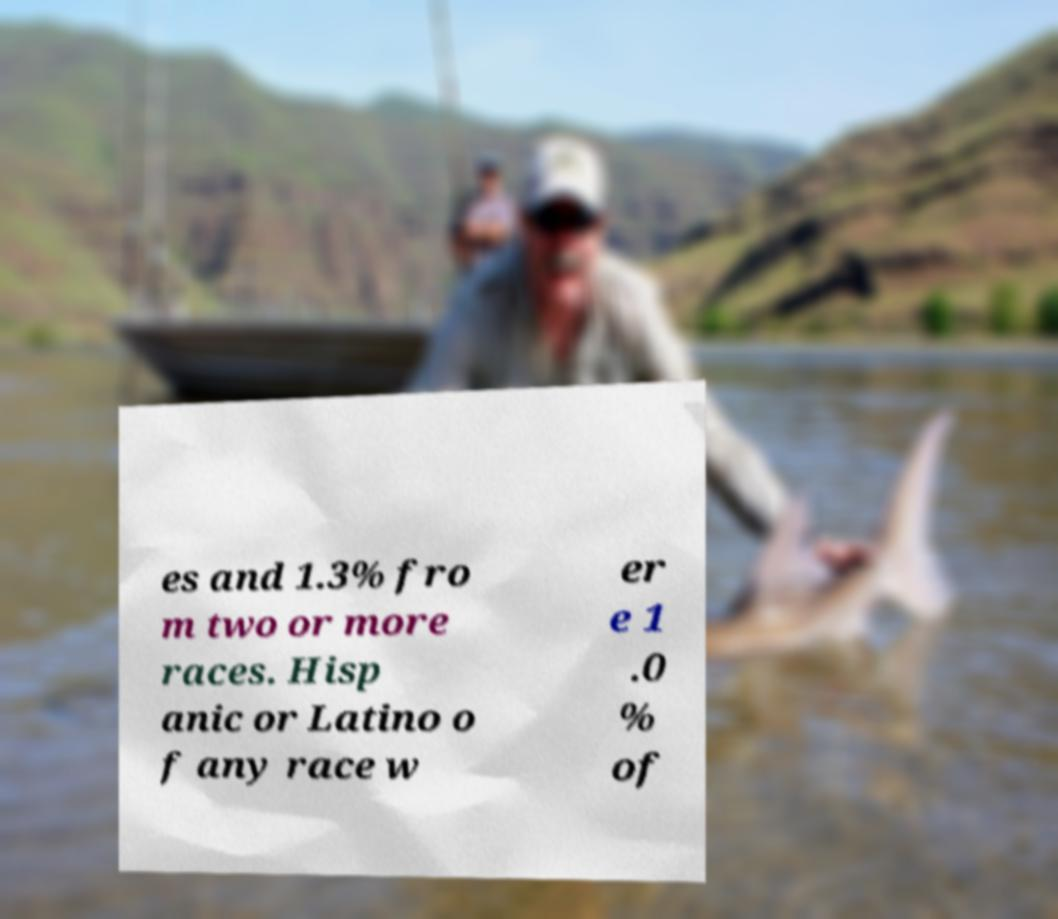What messages or text are displayed in this image? I need them in a readable, typed format. es and 1.3% fro m two or more races. Hisp anic or Latino o f any race w er e 1 .0 % of 